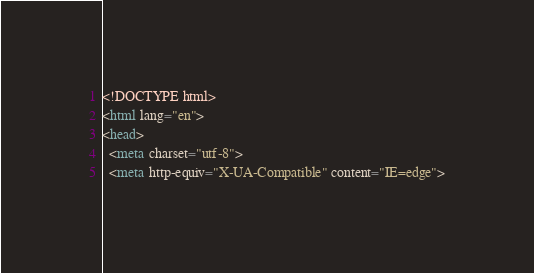<code> <loc_0><loc_0><loc_500><loc_500><_HTML_><!DOCTYPE html>
<html lang="en">
<head>
  <meta charset="utf-8">
  <meta http-equiv="X-UA-Compatible" content="IE=edge"></code> 